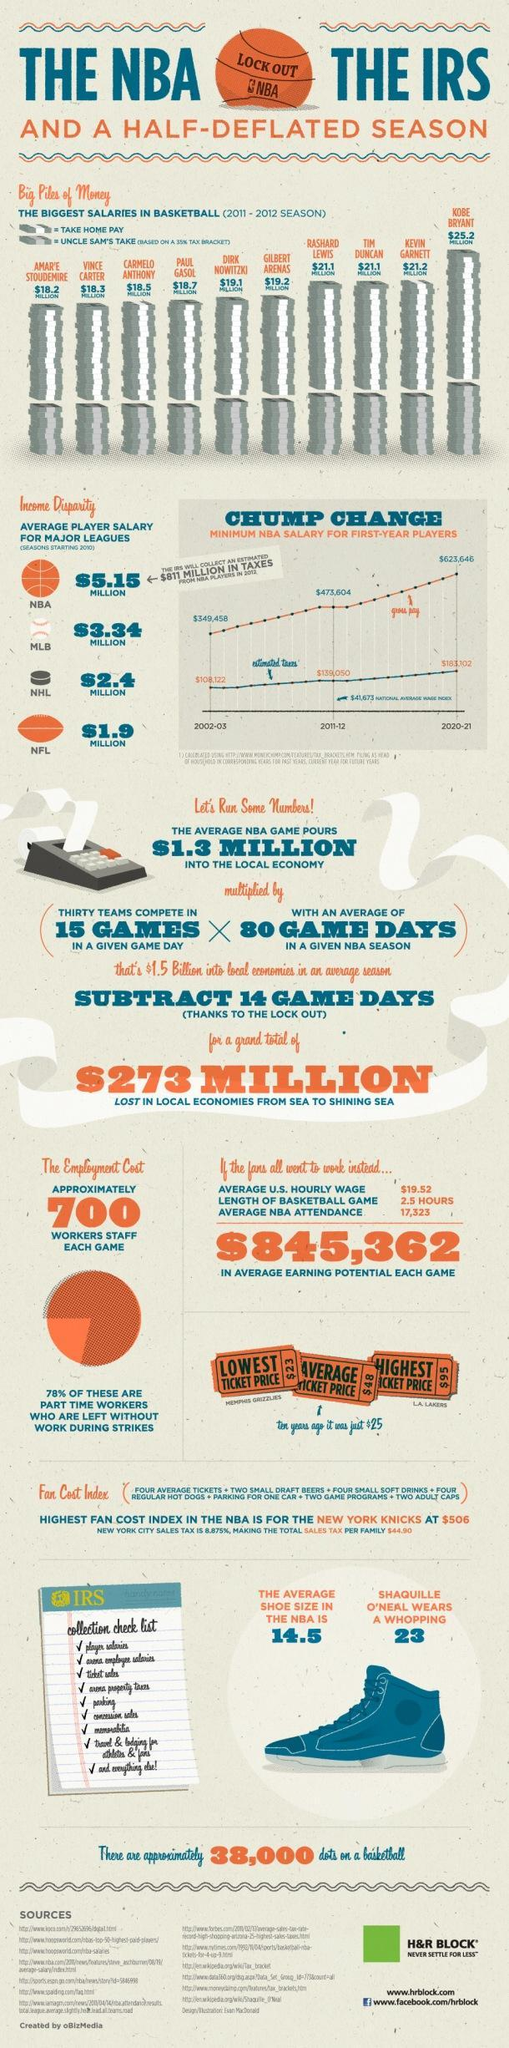Carmelo Anthony's salary is higher than whom
Answer the question with a short phrase. Amar'e Stoudemire, Vince Carter How many staff are required per game 700 What is the shoe size of Shaquille O'Neal 23 What is the highest ticket price $95 How many pointers in the collection checklist 9 Whose salaries are the same Rashard Lewis, Tim Duncan What is the lowest ticket price printed $23 What is the average ticket price $48 